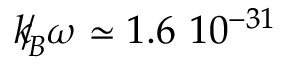<formula> <loc_0><loc_0><loc_500><loc_500>{ \slash \, k } _ { \, { B } } \omega \simeq 1 . 6 \ 1 0 ^ { - 3 1 }</formula> 